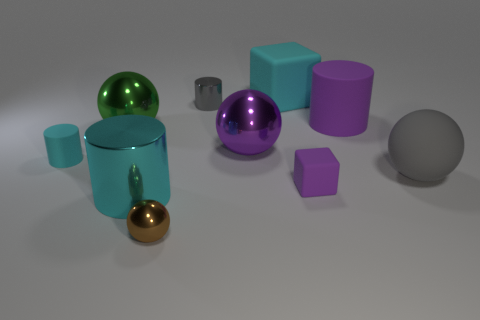Subtract all green cylinders. Subtract all purple spheres. How many cylinders are left? 4 Subtract all cylinders. How many objects are left? 6 Subtract all big matte things. Subtract all small purple matte blocks. How many objects are left? 6 Add 2 blocks. How many blocks are left? 4 Add 7 large red spheres. How many large red spheres exist? 7 Subtract 1 green spheres. How many objects are left? 9 